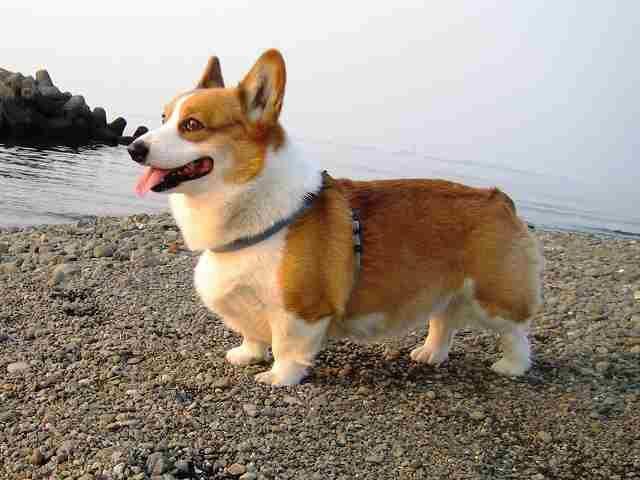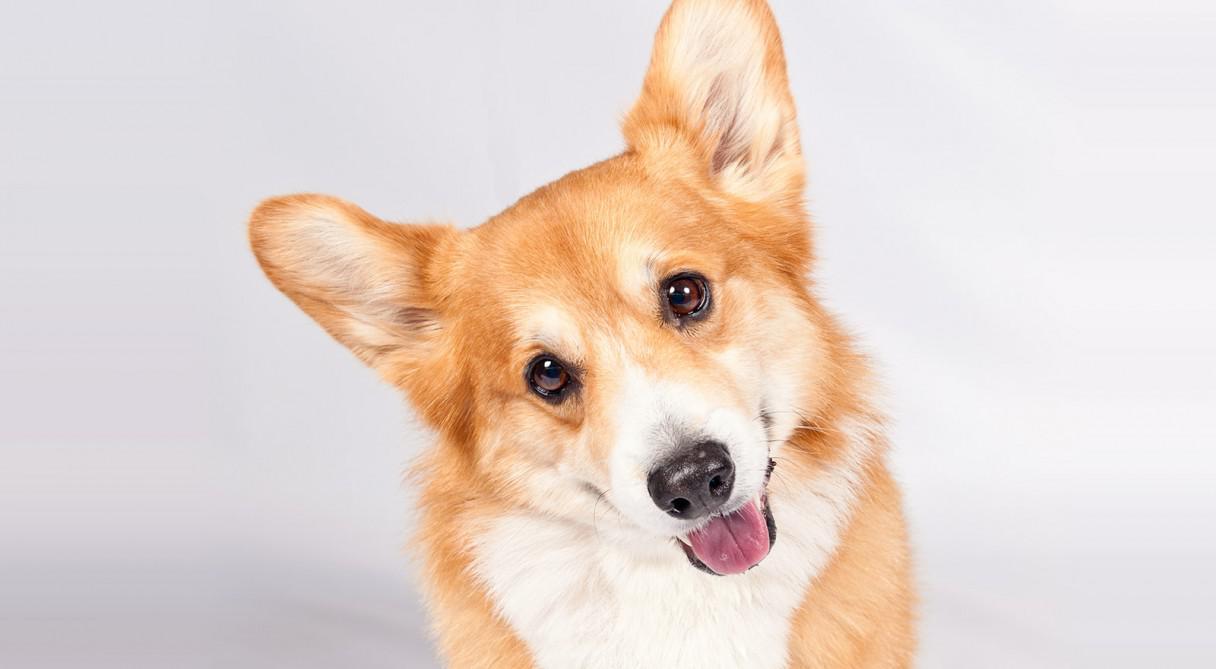The first image is the image on the left, the second image is the image on the right. Examine the images to the left and right. Is the description "The image on the right has a one dog with its tongue showing." accurate? Answer yes or no. Yes. The first image is the image on the left, the second image is the image on the right. Examine the images to the left and right. Is the description "All dogs are looking in the general direction of the camera." accurate? Answer yes or no. No. 